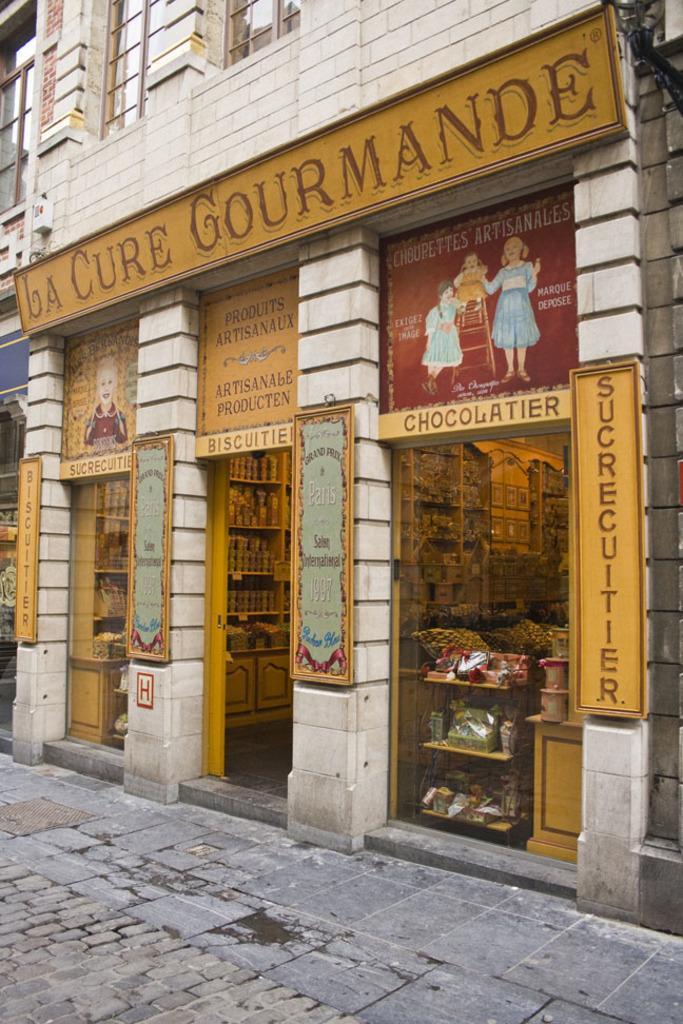Describe this image in one or two sentences. In this image, we can see a building, boards and we can see some stores. At the bottom, there is floor. 